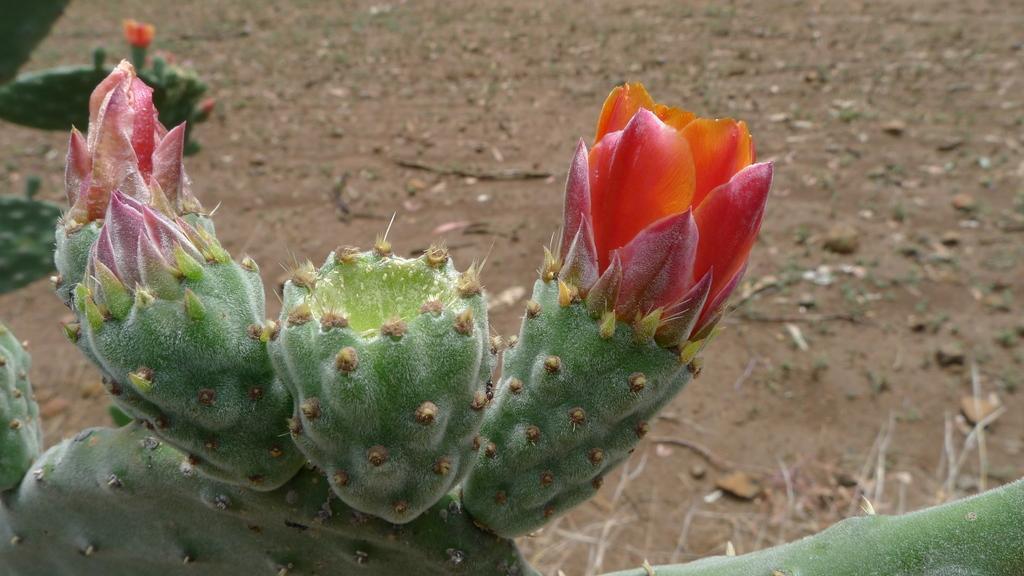Please provide a concise description of this image. Bottom of the image there are some plants. Behind the plants there is sand. 